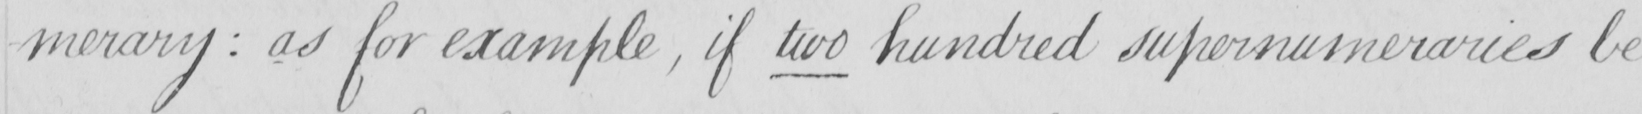Transcribe the text shown in this historical manuscript line. -merary  :  as for example , if two hundred supernumeraries be 